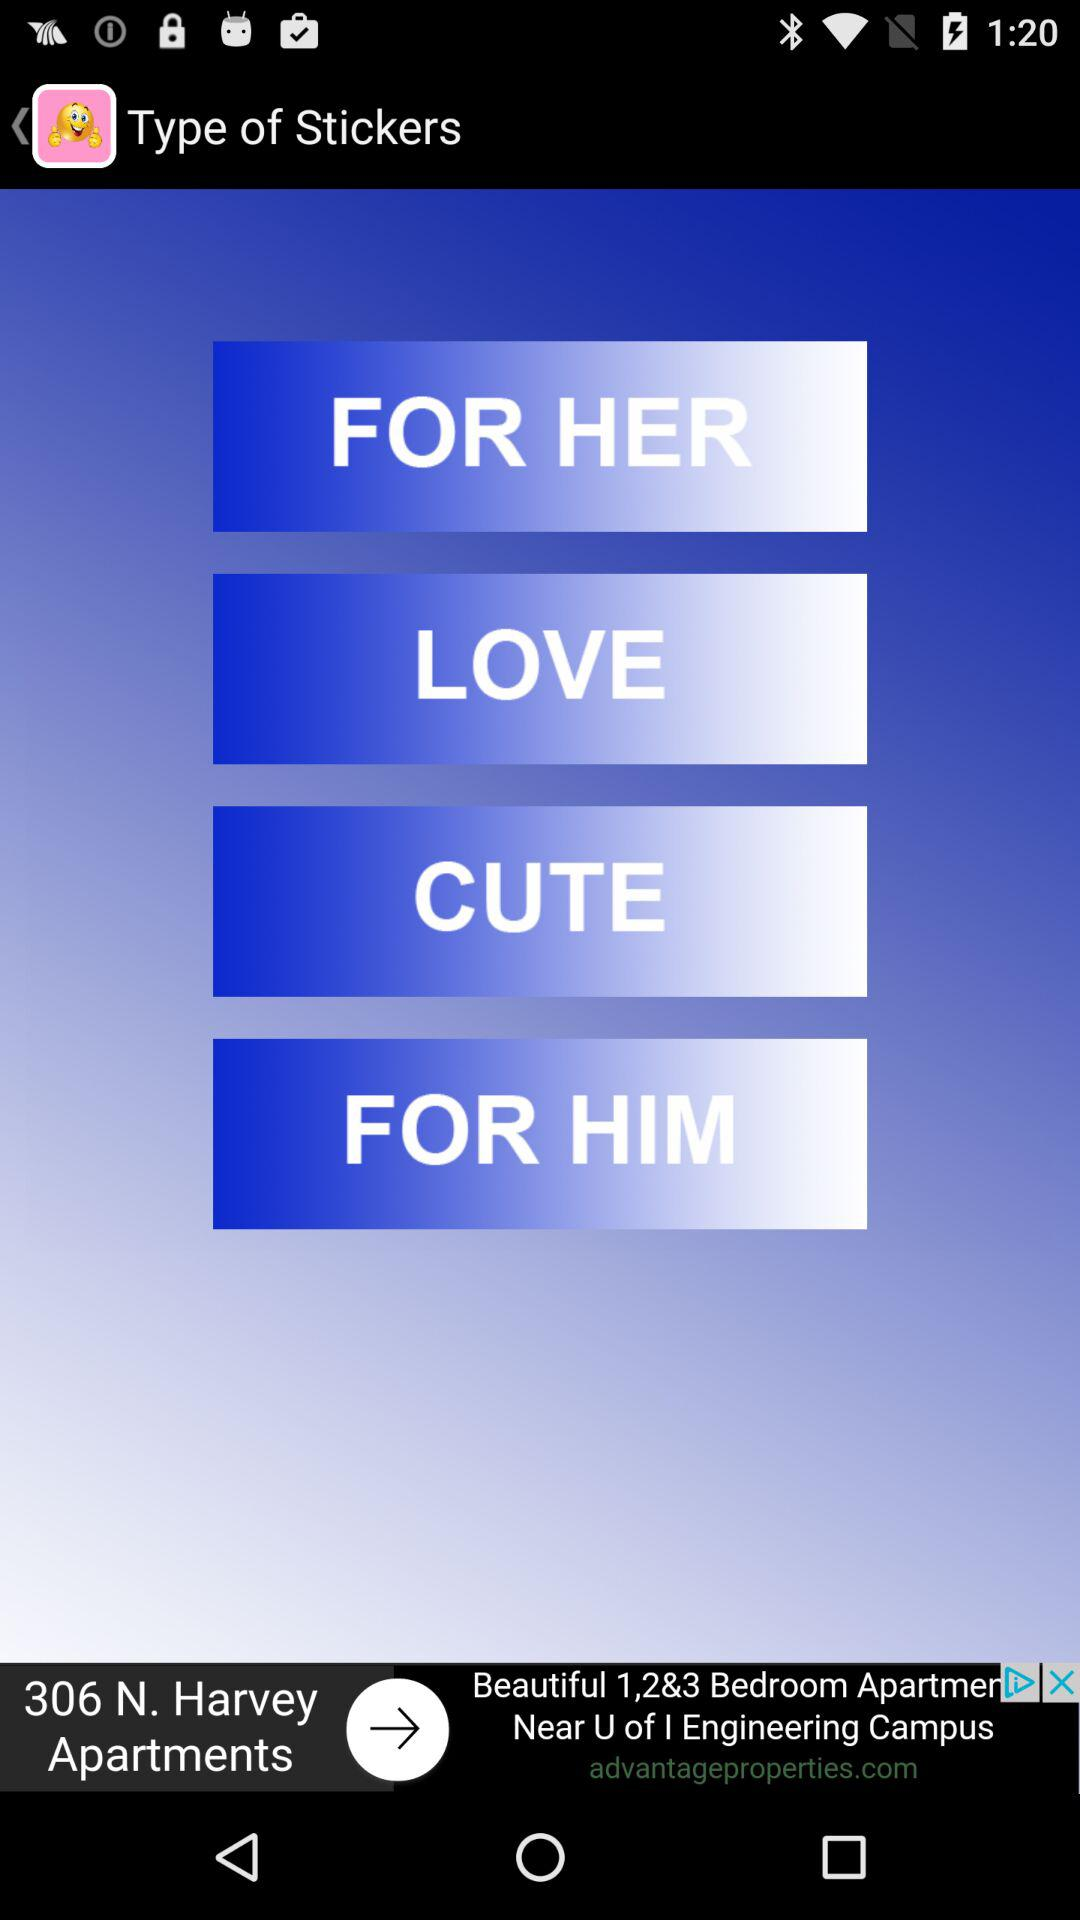How many types of stickers are there?
Answer the question using a single word or phrase. 4 